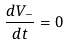<formula> <loc_0><loc_0><loc_500><loc_500>\frac { d V _ { - } } { d t } = 0</formula> 